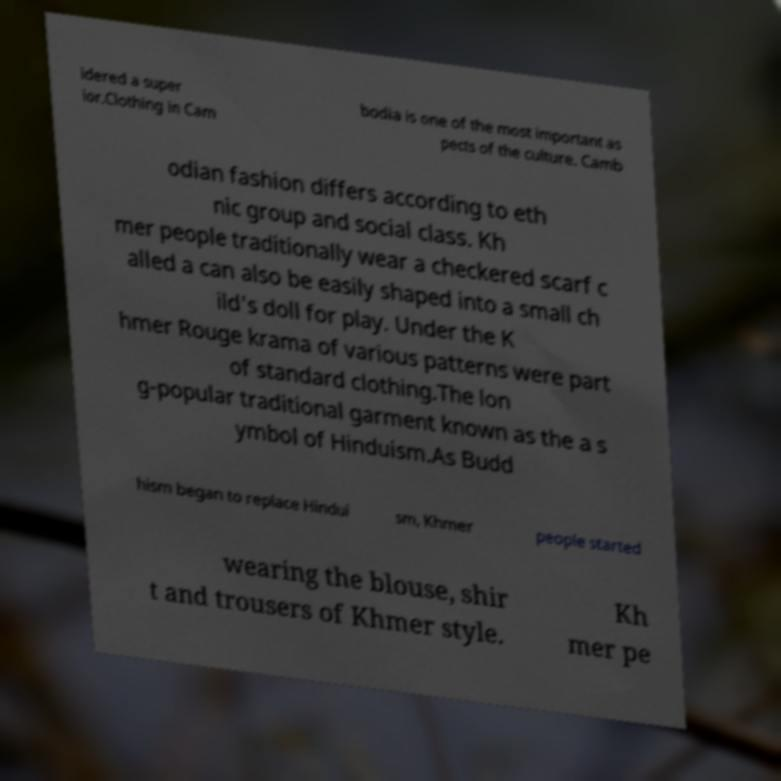Could you extract and type out the text from this image? idered a super ior.Clothing in Cam bodia is one of the most important as pects of the culture. Camb odian fashion differs according to eth nic group and social class. Kh mer people traditionally wear a checkered scarf c alled a can also be easily shaped into a small ch ild's doll for play. Under the K hmer Rouge krama of various patterns were part of standard clothing.The lon g-popular traditional garment known as the a s ymbol of Hinduism.As Budd hism began to replace Hindui sm, Khmer people started wearing the blouse, shir t and trousers of Khmer style. Kh mer pe 